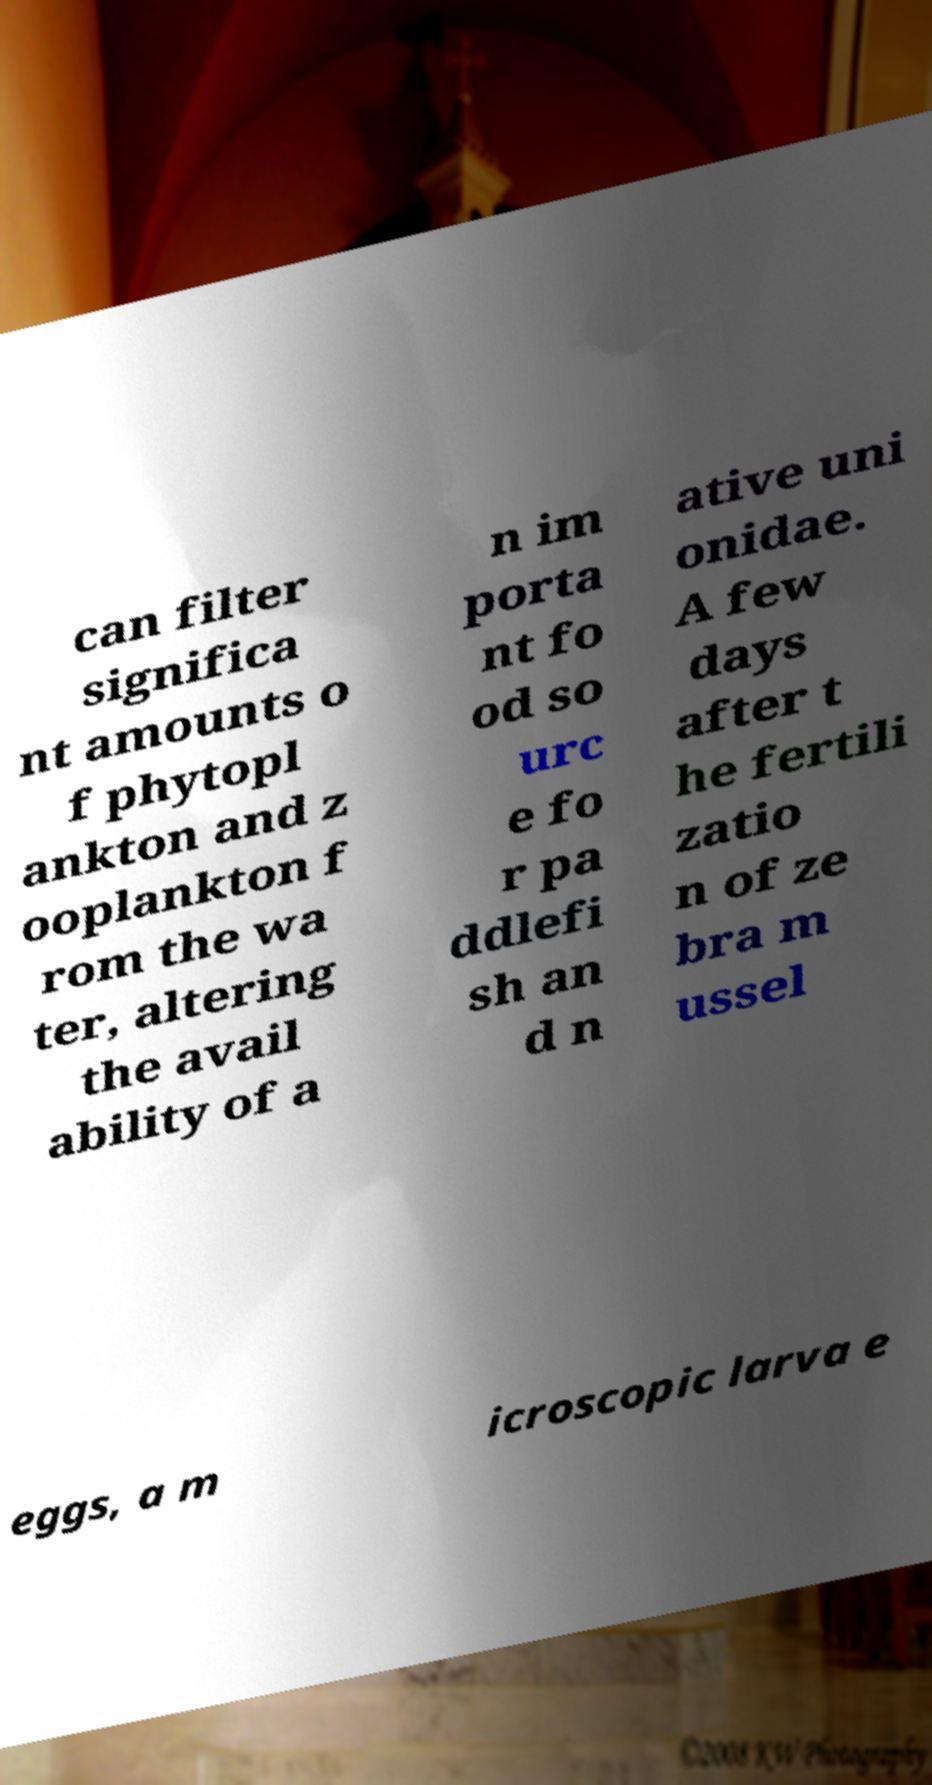There's text embedded in this image that I need extracted. Can you transcribe it verbatim? can filter significa nt amounts o f phytopl ankton and z ooplankton f rom the wa ter, altering the avail ability of a n im porta nt fo od so urc e fo r pa ddlefi sh an d n ative uni onidae. A few days after t he fertili zatio n of ze bra m ussel eggs, a m icroscopic larva e 